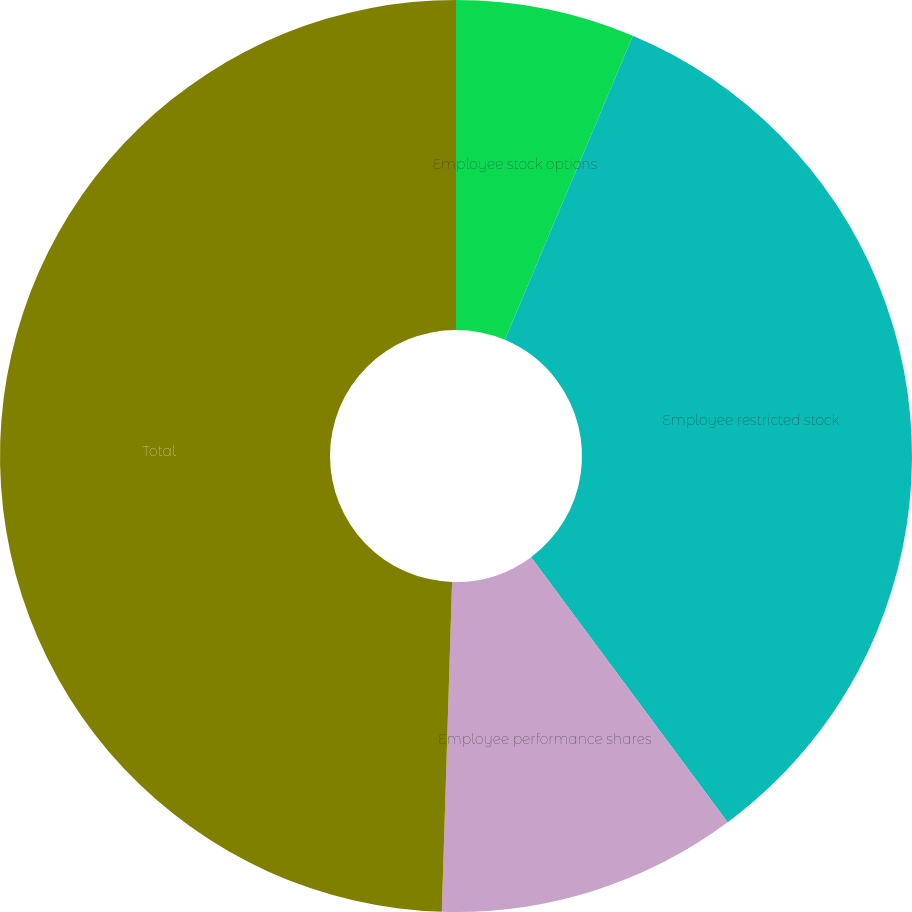Convert chart to OTSL. <chart><loc_0><loc_0><loc_500><loc_500><pie_chart><fcel>Employee stock options<fcel>Employee restricted stock<fcel>Employee performance shares<fcel>Total<nl><fcel>6.34%<fcel>33.5%<fcel>10.65%<fcel>49.5%<nl></chart> 